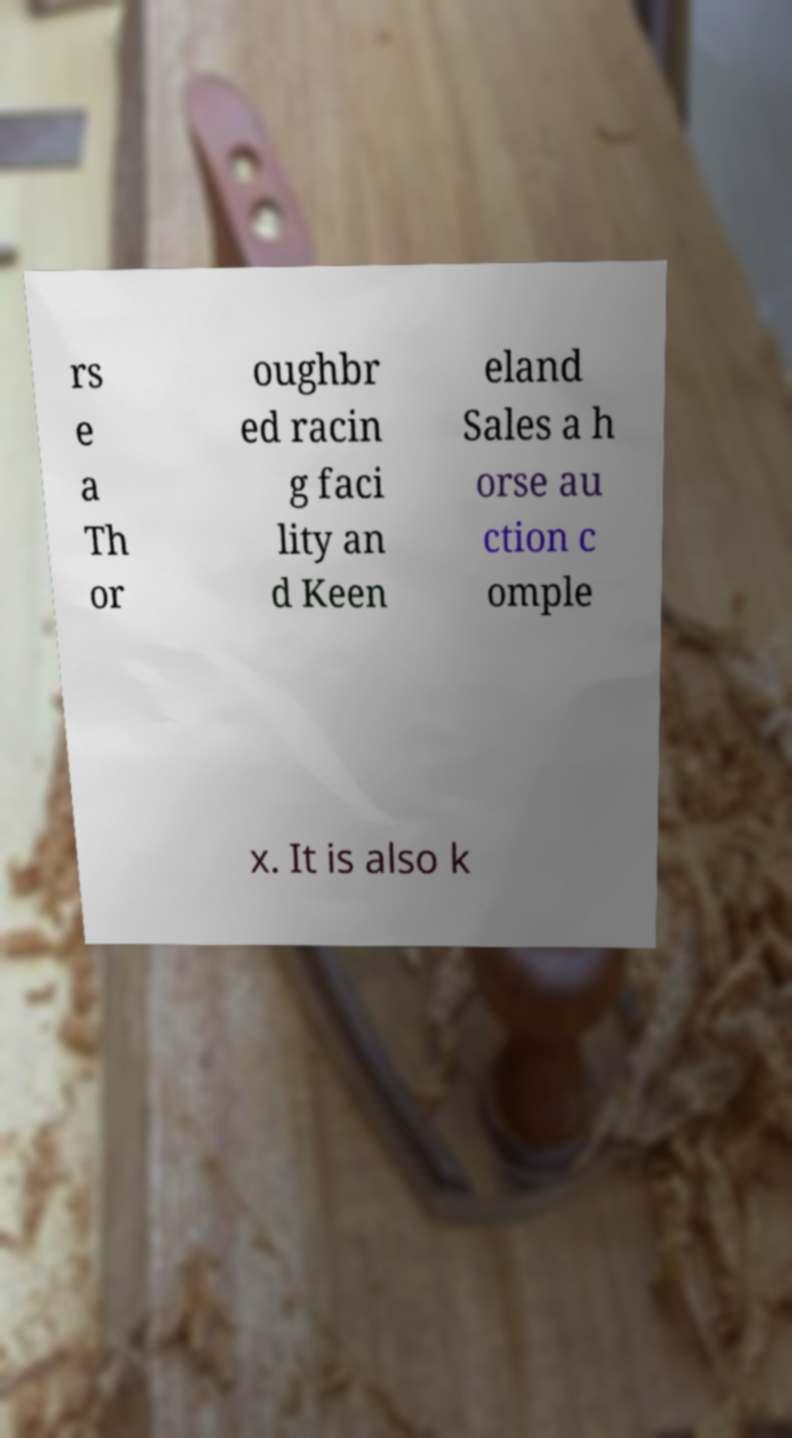Please identify and transcribe the text found in this image. rs e a Th or oughbr ed racin g faci lity an d Keen eland Sales a h orse au ction c omple x. It is also k 